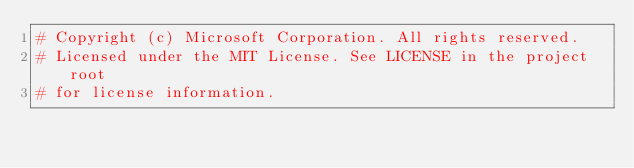Convert code to text. <code><loc_0><loc_0><loc_500><loc_500><_Python_># Copyright (c) Microsoft Corporation. All rights reserved.
# Licensed under the MIT License. See LICENSE in the project root
# for license information.
</code> 